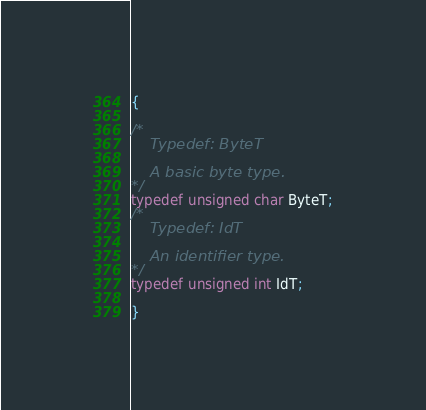<code> <loc_0><loc_0><loc_500><loc_500><_C_>{

/*
	Typedef: ByteT

	A basic byte type.
*/
typedef unsigned char ByteT;
/*
	Typedef: IdT

	An identifier type.
*/
typedef unsigned int IdT;

}
</code> 